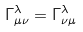Convert formula to latex. <formula><loc_0><loc_0><loc_500><loc_500>\Gamma _ { \mu \nu } ^ { \lambda } = \Gamma _ { \nu \mu } ^ { \lambda }</formula> 